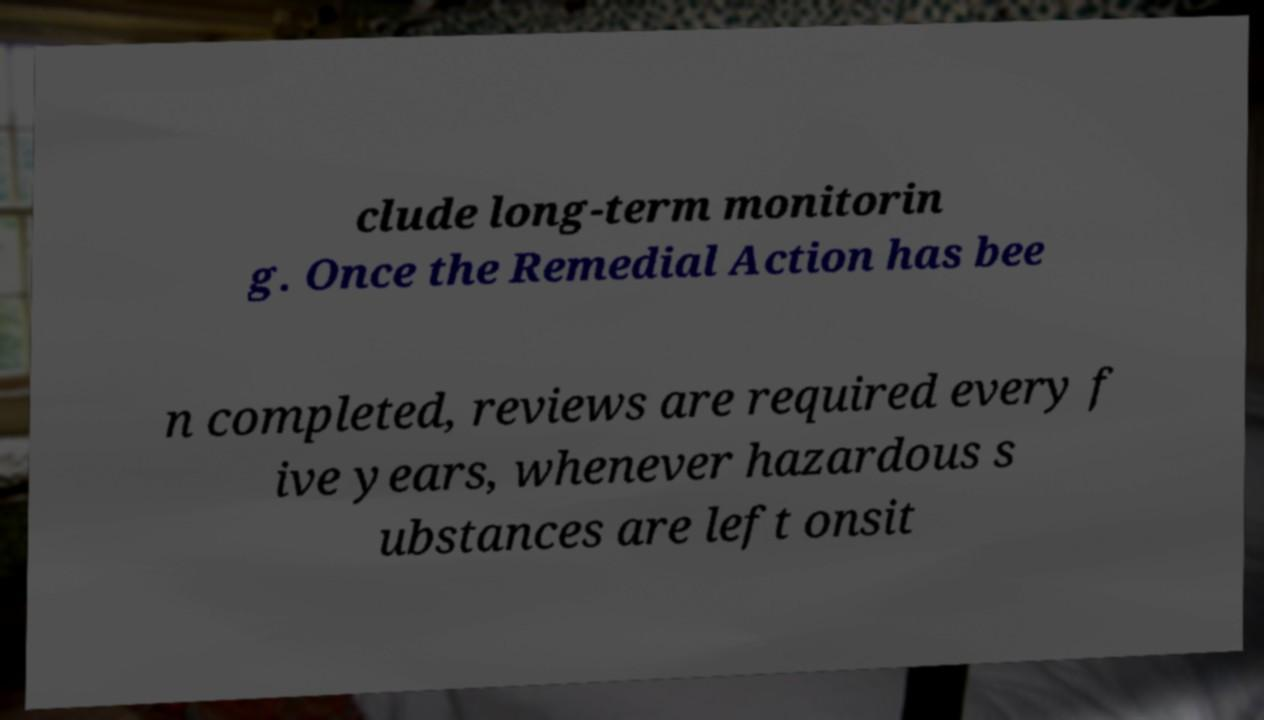Can you accurately transcribe the text from the provided image for me? clude long-term monitorin g. Once the Remedial Action has bee n completed, reviews are required every f ive years, whenever hazardous s ubstances are left onsit 